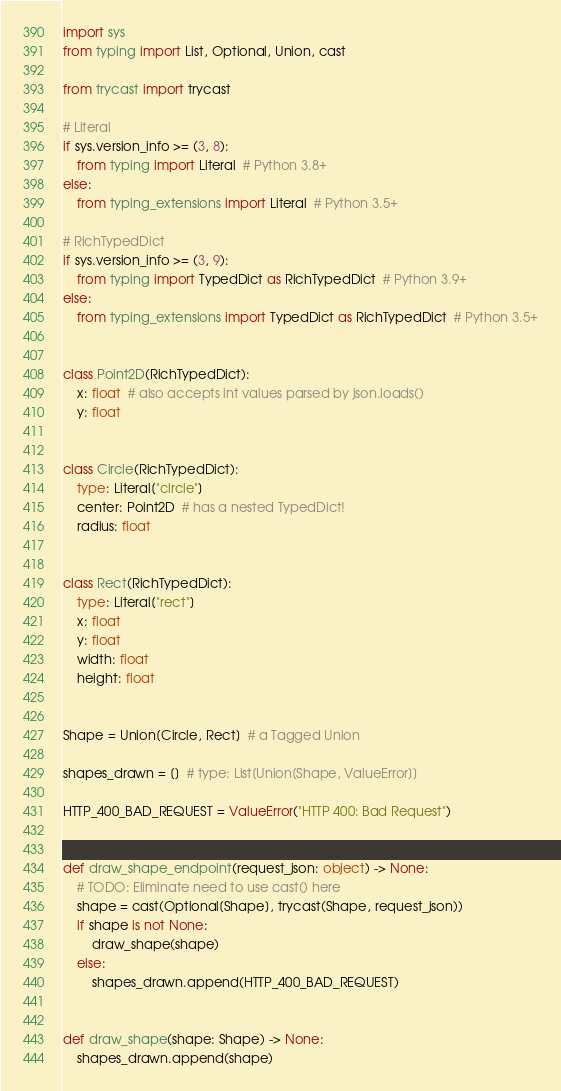Convert code to text. <code><loc_0><loc_0><loc_500><loc_500><_Python_>import sys
from typing import List, Optional, Union, cast

from trycast import trycast

# Literal
if sys.version_info >= (3, 8):
    from typing import Literal  # Python 3.8+
else:
    from typing_extensions import Literal  # Python 3.5+

# RichTypedDict
if sys.version_info >= (3, 9):
    from typing import TypedDict as RichTypedDict  # Python 3.9+
else:
    from typing_extensions import TypedDict as RichTypedDict  # Python 3.5+


class Point2D(RichTypedDict):
    x: float  # also accepts int values parsed by json.loads()
    y: float


class Circle(RichTypedDict):
    type: Literal["circle"]
    center: Point2D  # has a nested TypedDict!
    radius: float


class Rect(RichTypedDict):
    type: Literal["rect"]
    x: float
    y: float
    width: float
    height: float


Shape = Union[Circle, Rect]  # a Tagged Union

shapes_drawn = []  # type: List[Union[Shape, ValueError]]

HTTP_400_BAD_REQUEST = ValueError("HTTP 400: Bad Request")


def draw_shape_endpoint(request_json: object) -> None:
    # TODO: Eliminate need to use cast() here
    shape = cast(Optional[Shape], trycast(Shape, request_json))
    if shape is not None:
        draw_shape(shape)
    else:
        shapes_drawn.append(HTTP_400_BAD_REQUEST)


def draw_shape(shape: Shape) -> None:
    shapes_drawn.append(shape)
</code> 